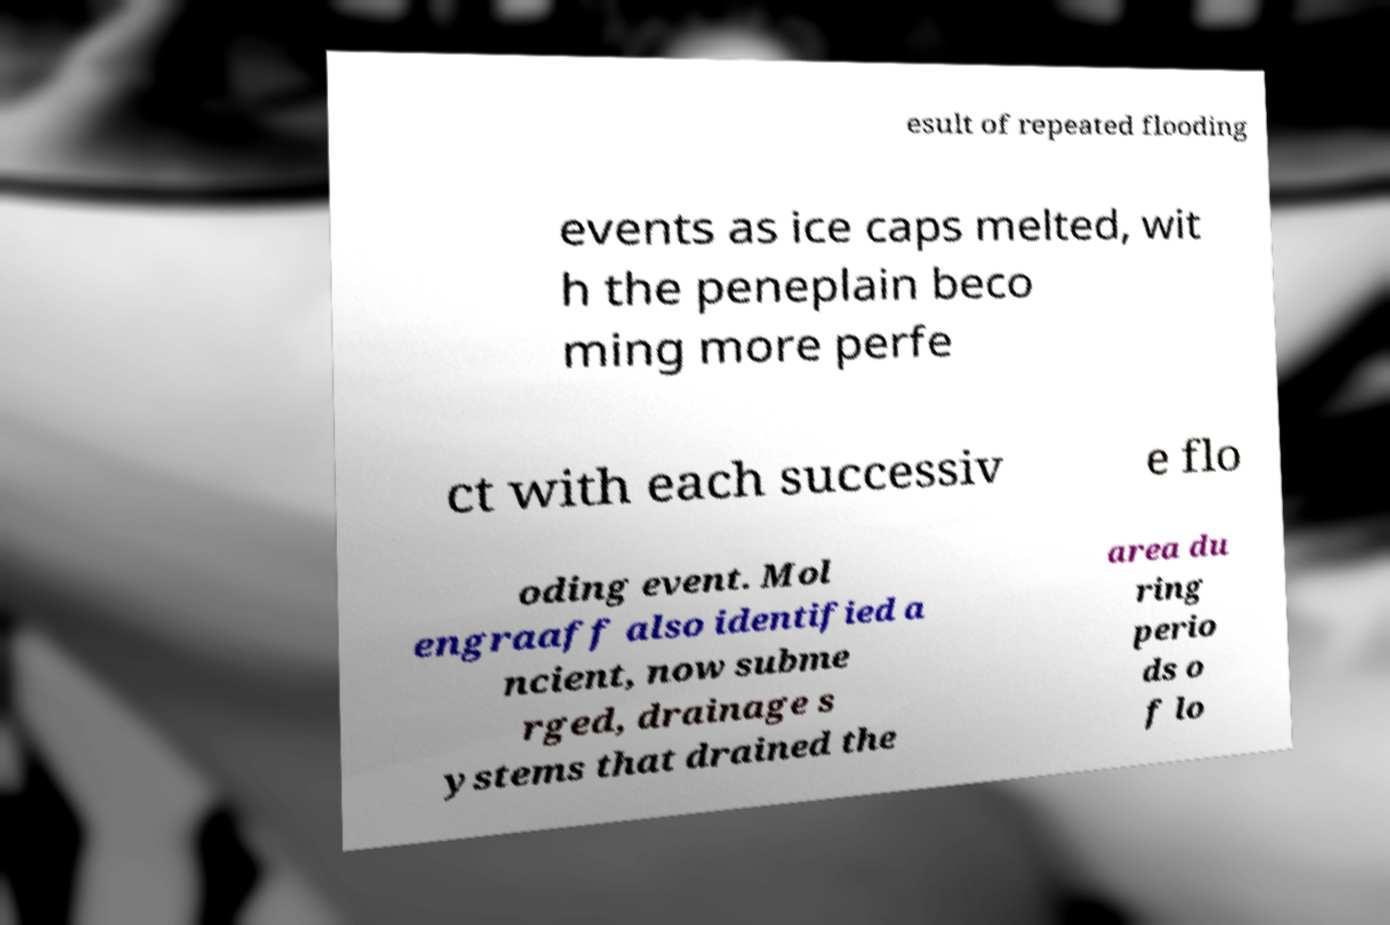Could you assist in decoding the text presented in this image and type it out clearly? esult of repeated flooding events as ice caps melted, wit h the peneplain beco ming more perfe ct with each successiv e flo oding event. Mol engraaff also identified a ncient, now subme rged, drainage s ystems that drained the area du ring perio ds o f lo 